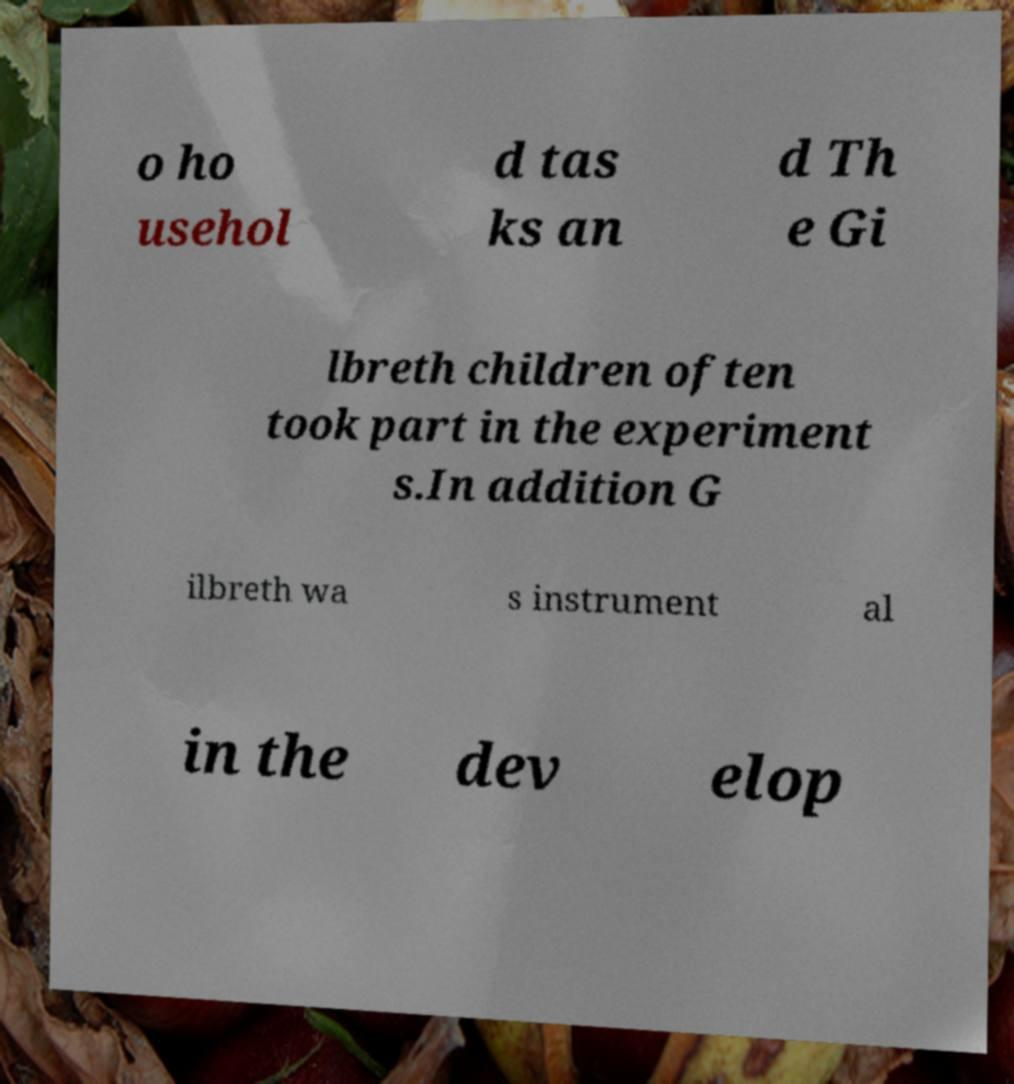For documentation purposes, I need the text within this image transcribed. Could you provide that? o ho usehol d tas ks an d Th e Gi lbreth children often took part in the experiment s.In addition G ilbreth wa s instrument al in the dev elop 